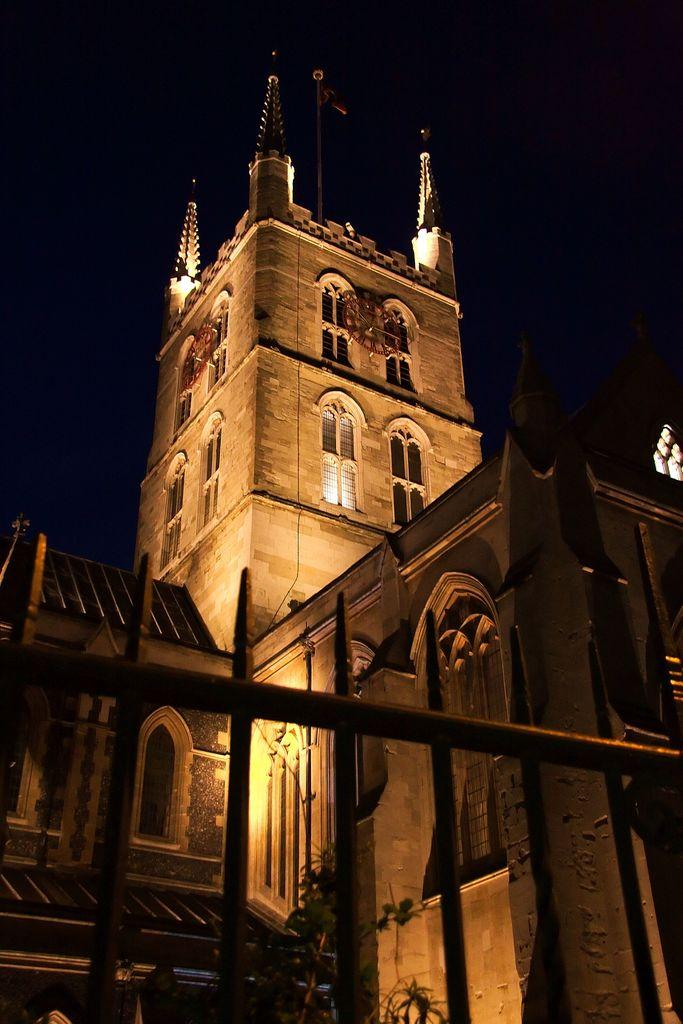What type of barrier can be seen in the image? There is a fence in the image. What type of living organism is present in the image? There is a plant in the image. What can be seen in the distance in the image? There are buildings, windows, and a flagpole on a building in the background of the image. What type of illumination is present in the background of the image? Lights are present in the background of the image. Can you see a squirrel climbing the flagpole in the image? There is no squirrel present in the image; it only features a fence, a plant, buildings, windows, a flagpole, and lights. 